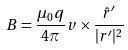Convert formula to latex. <formula><loc_0><loc_0><loc_500><loc_500>B = \frac { \mu _ { 0 } q } { 4 \pi } v \times \frac { \hat { r } ^ { \prime } } { | r ^ { \prime } | ^ { 2 } }</formula> 